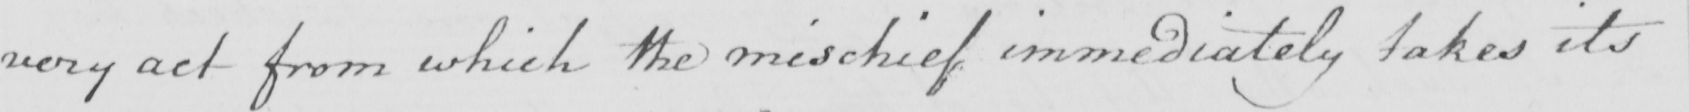Can you read and transcribe this handwriting? very act from which the mischief immediately takes its 